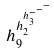Convert formula to latex. <formula><loc_0><loc_0><loc_500><loc_500>h _ { 9 } ^ { h _ { 2 } ^ { h _ { 3 } ^ { - ^ { - ^ { - } } } } }</formula> 